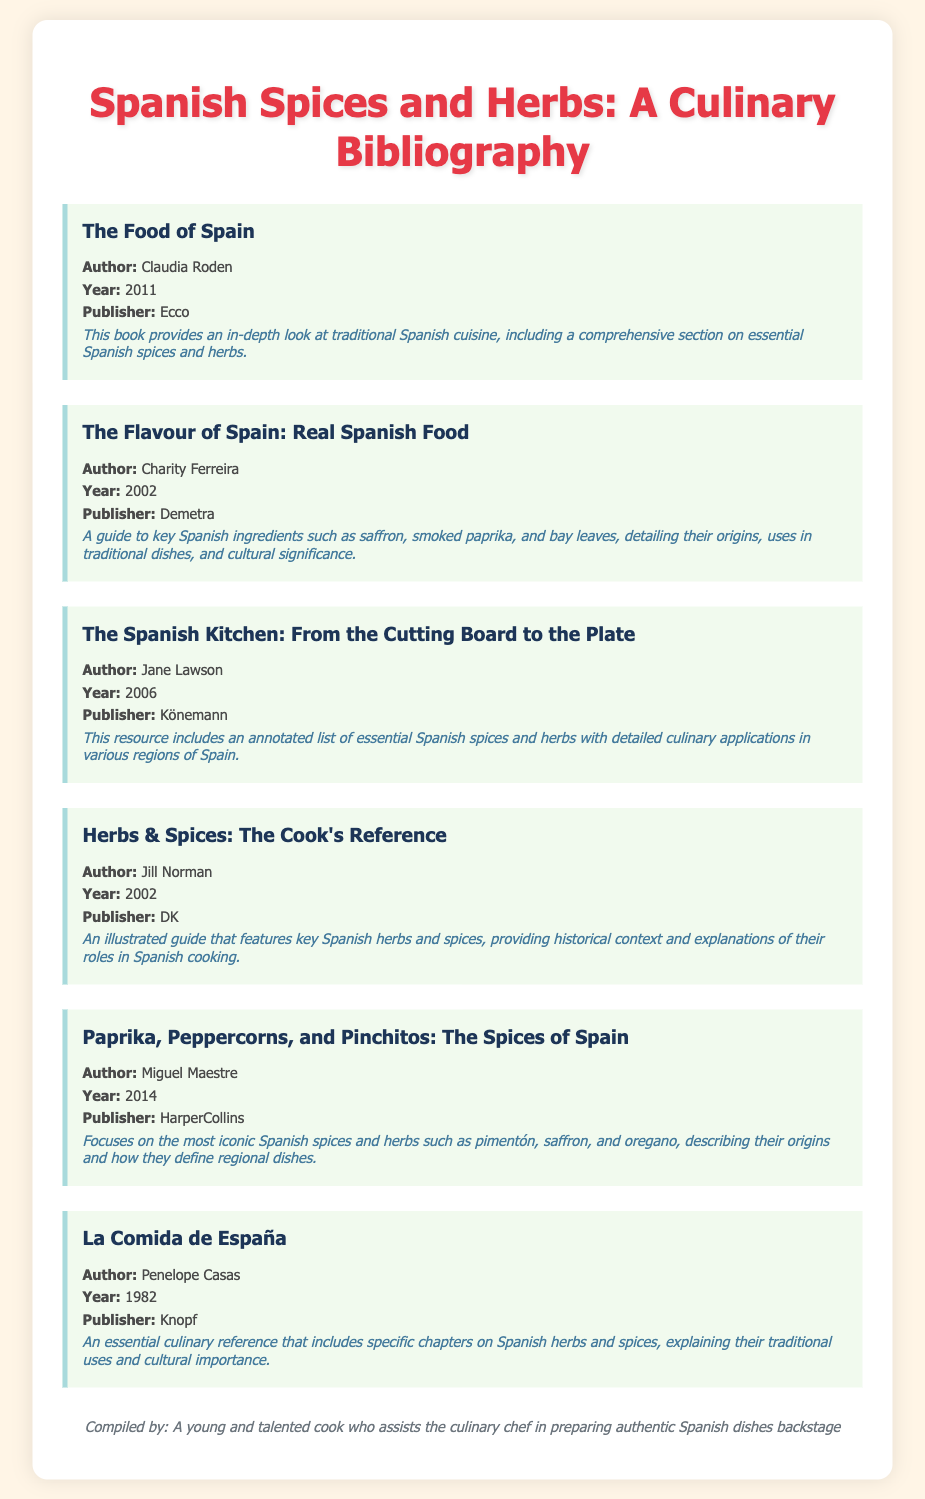What is the title of the first book? The title of the first book listed in the bibliography is "The Food of Spain."
Answer: The Food of Spain Who is the author of "The Flavour of Spain"? The author of "The Flavour of Spain: Real Spanish Food" is Charity Ferreira.
Answer: Charity Ferreira What year was "Paprika, Peppercorns, and Pinchitos" published? "Paprika, Peppercorns, and Pinchitos: The Spices of Spain" was published in 2014.
Answer: 2014 Which publisher released "The Spanish Kitchen"? "The Spanish Kitchen: From the Cutting Board to the Plate" was published by Könemann.
Answer: Könemann What is the primary focus of Miguel Maestre's book? Miguel Maestre's book focuses on the most iconic Spanish spices and herbs.
Answer: Iconic Spanish spices and herbs Which herb is often highlighted for its cultural significance in Spanish cooking? Saffron is often highlighted for its cultural significance in Spanish cooking.
Answer: Saffron What type of document is this listing? This listing is a bibliography of essential Spanish spices and herbs.
Answer: Bibliography 